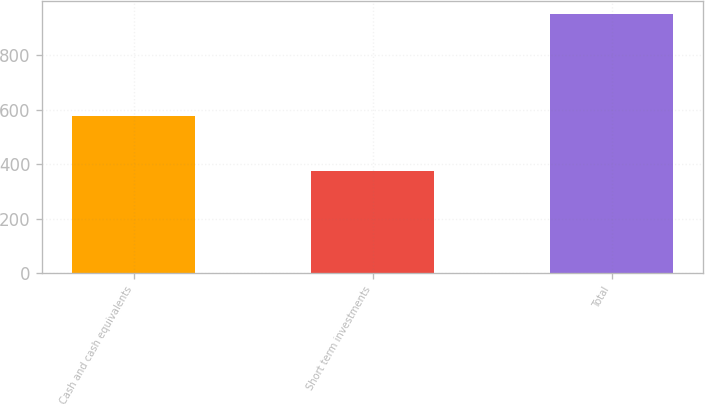Convert chart to OTSL. <chart><loc_0><loc_0><loc_500><loc_500><bar_chart><fcel>Cash and cash equivalents<fcel>Short term investments<fcel>Total<nl><fcel>577.6<fcel>373.7<fcel>951.3<nl></chart> 